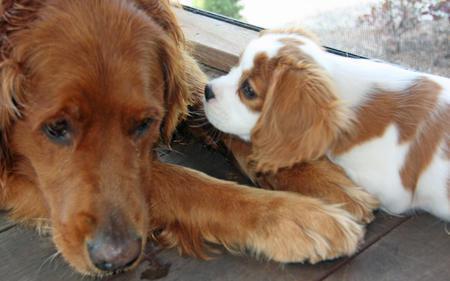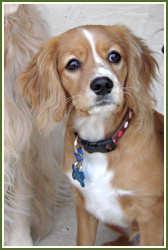The first image is the image on the left, the second image is the image on the right. For the images shown, is this caption "There ar no more than 3 dogs in the image pair" true? Answer yes or no. Yes. The first image is the image on the left, the second image is the image on the right. Examine the images to the left and right. Is the description "There are only three dogs." accurate? Answer yes or no. Yes. 